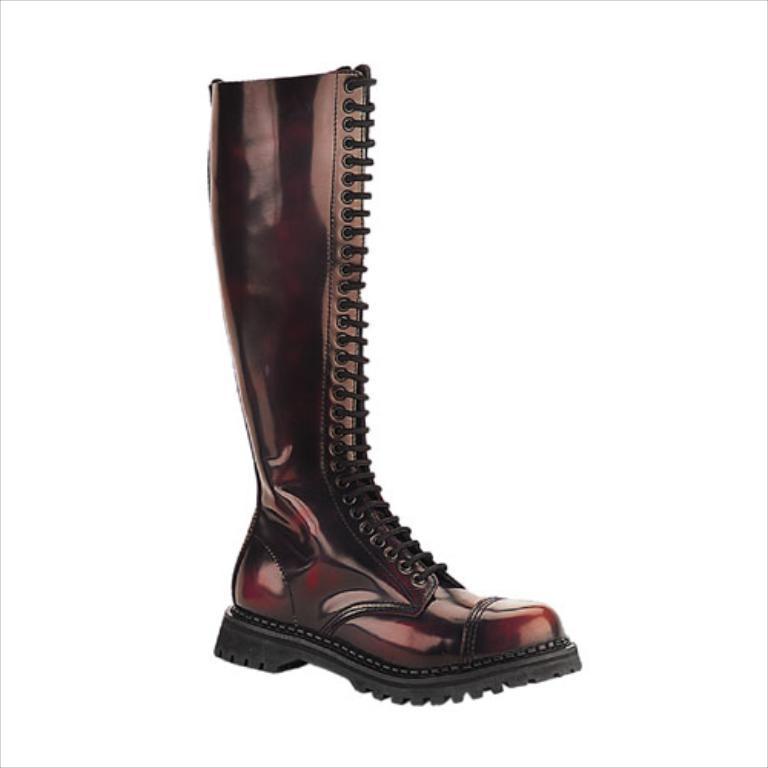In one or two sentences, can you explain what this image depicts? In this picture, it seems like gumboot in the foreground. 